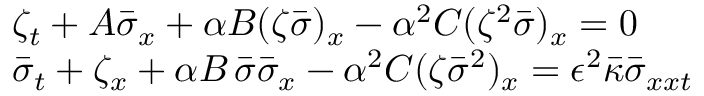Convert formula to latex. <formula><loc_0><loc_0><loc_500><loc_500>\begin{array} { r l } & { \zeta _ { t } + A \bar { \sigma } _ { x } + \alpha B ( \zeta \bar { \sigma } ) _ { x } - \alpha ^ { 2 } C ( \zeta ^ { 2 } \bar { \sigma } ) _ { x } = 0 } \\ & { \bar { \sigma } _ { t } + \zeta _ { x } + \alpha B \, \bar { \sigma } \bar { \sigma } _ { x } - \alpha ^ { 2 } C ( \zeta \bar { \sigma } ^ { 2 } ) _ { x } = \epsilon ^ { 2 } \bar { \kappa } \bar { \sigma } _ { x x t } } \end{array}</formula> 